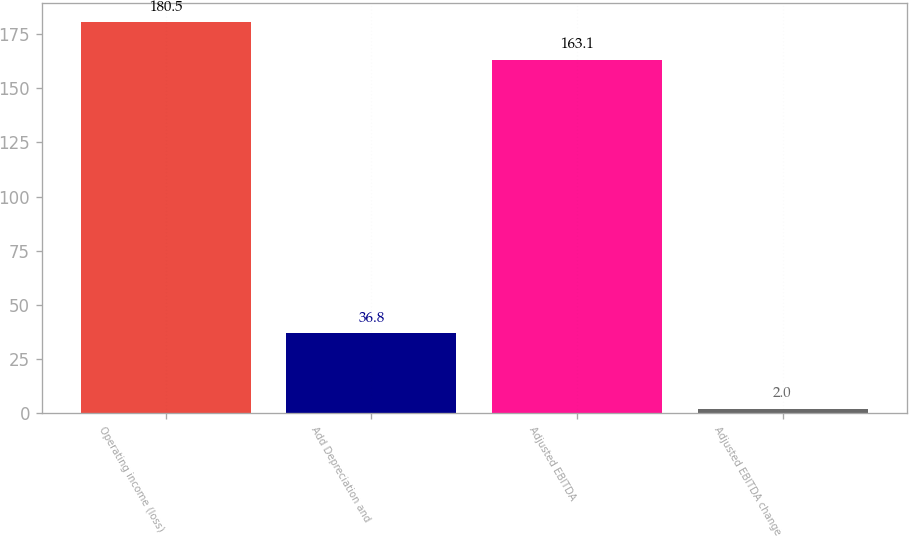Convert chart. <chart><loc_0><loc_0><loc_500><loc_500><bar_chart><fcel>Operating income (loss)<fcel>Add Depreciation and<fcel>Adjusted EBITDA<fcel>Adjusted EBITDA change<nl><fcel>180.5<fcel>36.8<fcel>163.1<fcel>2<nl></chart> 